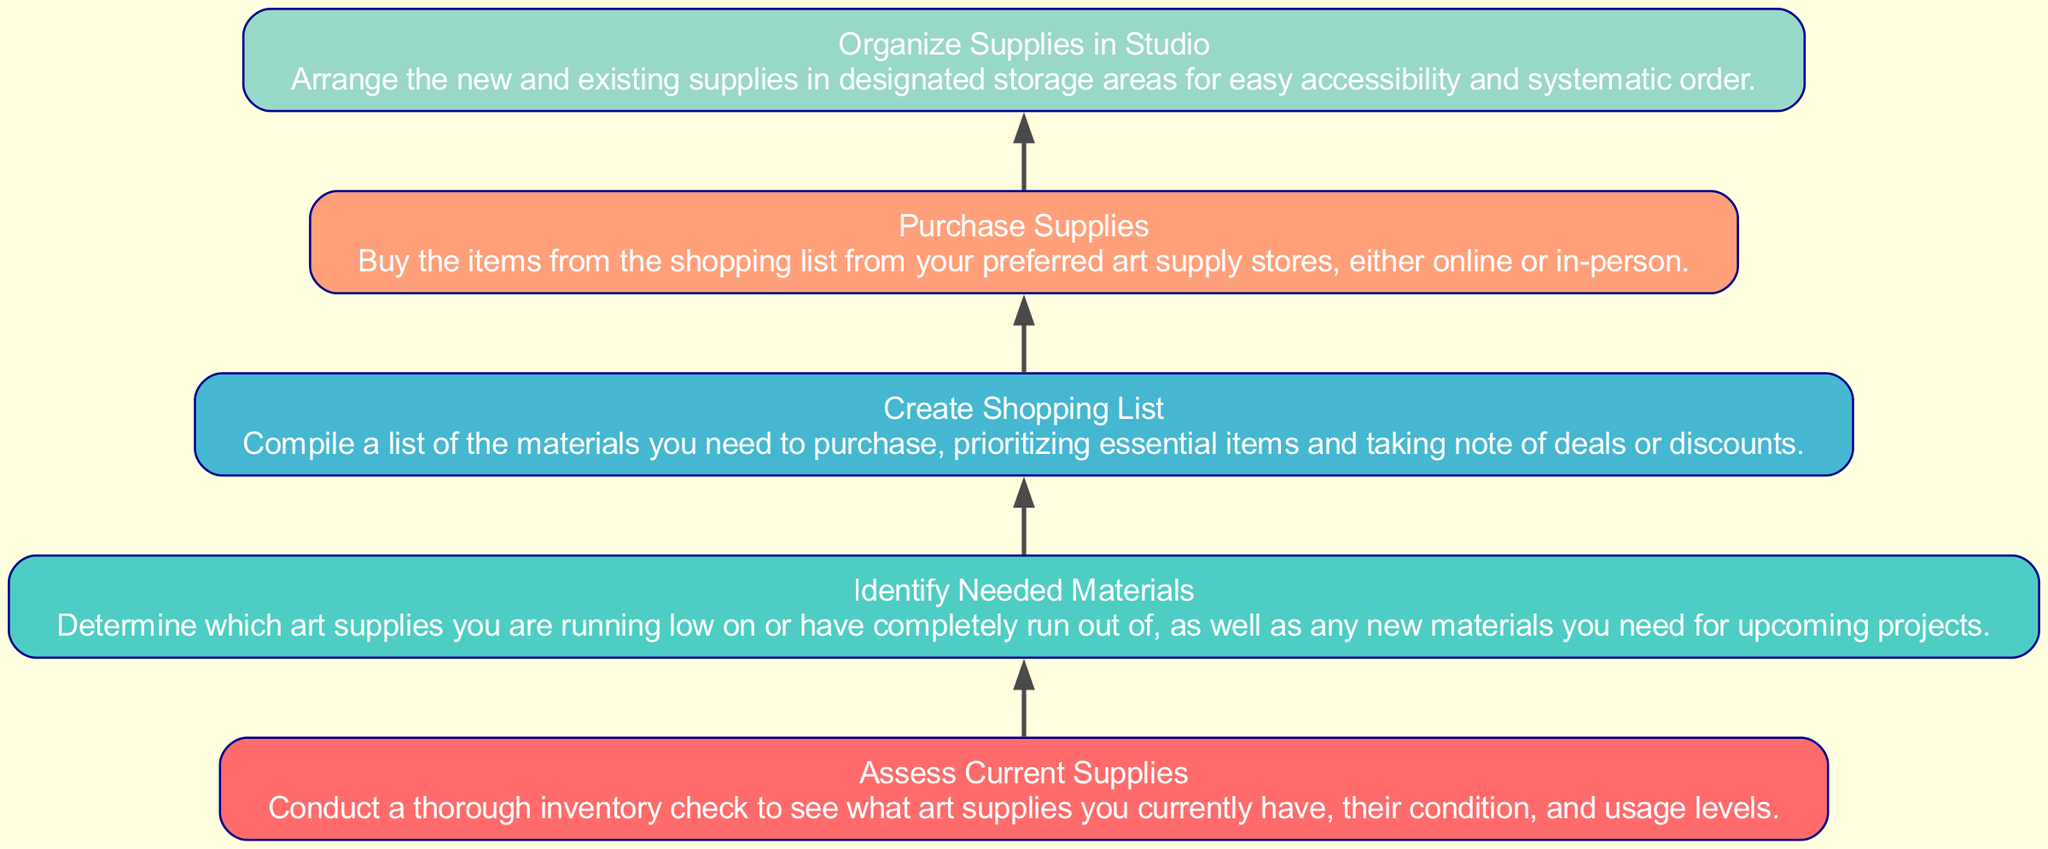What is the starting point of the flow chart? The flow chart begins with the node labeled "Assess Current Supplies." This is the first process and indicates that you must first check what is currently in stock before moving forward.
Answer: Assess Current Supplies How many total nodes are present in the diagram? By counting the five distinct processes listed, we determine that there are five total nodes in the flow chart. Each of these represents a step in managing art supplies inventory.
Answer: Five What is the last step before organizing supplies in the studio? The step before "Organize Supplies in Studio" is "Purchase Supplies." This indicates that you must buy the necessary materials before you can arrange them.
Answer: Purchase Supplies Which step directly follows identifying needed materials? The step that directly follows "Identify Needed Materials" is "Create Shopping List." This indicates that after determining what supplies are required, you must compile them into a list before making purchases.
Answer: Create Shopping List What color is used for the "Create Shopping List" node? The "Create Shopping List" node is filled with a light orange color as indicated in the legend regarding the custom fill colors assigned in the flow chart.
Answer: Light orange 